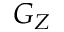<formula> <loc_0><loc_0><loc_500><loc_500>G _ { Z }</formula> 